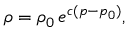<formula> <loc_0><loc_0><loc_500><loc_500>\rho = \rho _ { 0 } \, e ^ { c ( p - p _ { 0 } ) } ,</formula> 